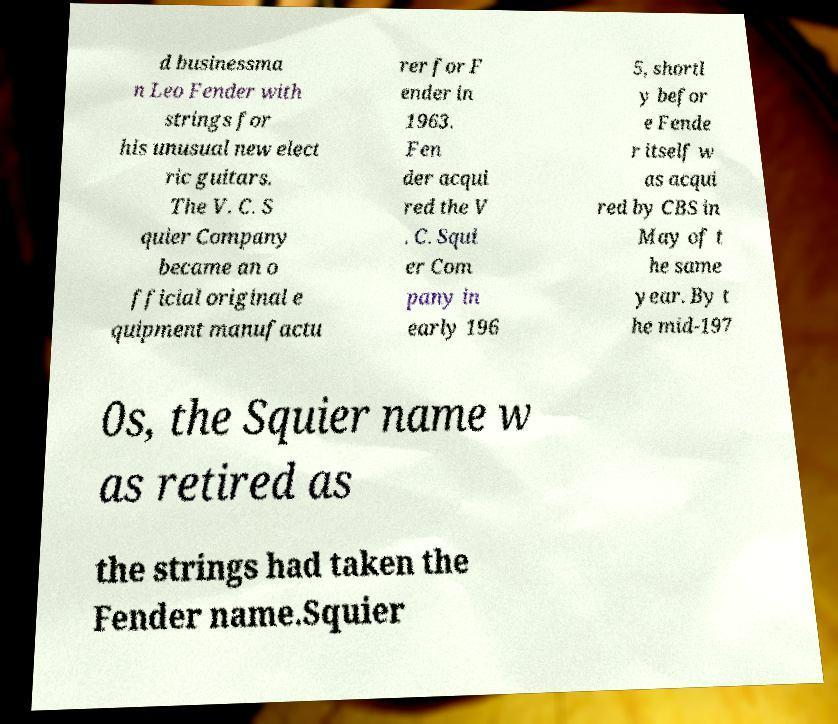Could you extract and type out the text from this image? d businessma n Leo Fender with strings for his unusual new elect ric guitars. The V. C. S quier Company became an o fficial original e quipment manufactu rer for F ender in 1963. Fen der acqui red the V . C. Squi er Com pany in early 196 5, shortl y befor e Fende r itself w as acqui red by CBS in May of t he same year. By t he mid-197 0s, the Squier name w as retired as the strings had taken the Fender name.Squier 